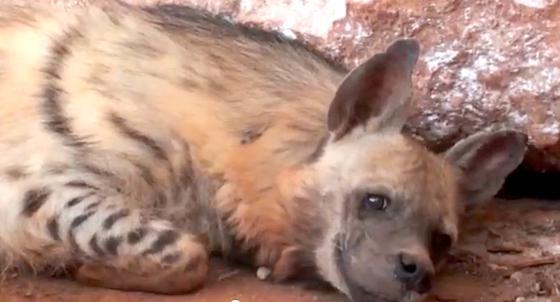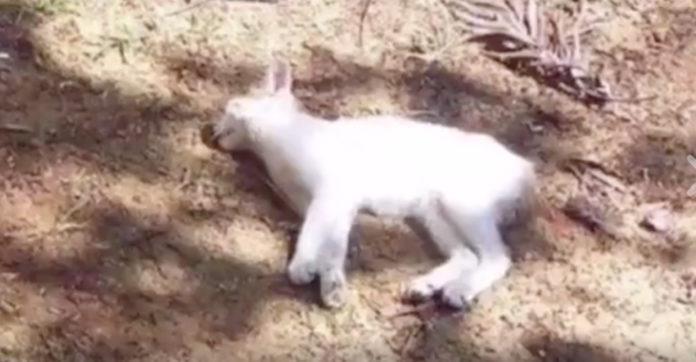The first image is the image on the left, the second image is the image on the right. Examine the images to the left and right. Is the description "Some of the hyenas are laying down." accurate? Answer yes or no. Yes. 